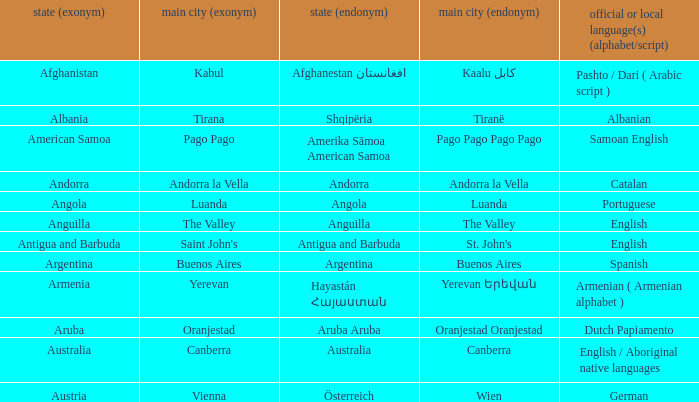How many capital cities does Australia have? 1.0. 